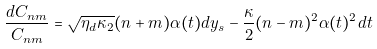Convert formula to latex. <formula><loc_0><loc_0><loc_500><loc_500>\frac { d C _ { n m } } { C _ { n m } } = \sqrt { \eta _ { d } \kappa _ { 2 } } ( n + m ) \alpha ( t ) d y _ { s } - \frac { \kappa } { 2 } ( n - m ) ^ { 2 } \alpha ( t ) ^ { 2 } d t</formula> 